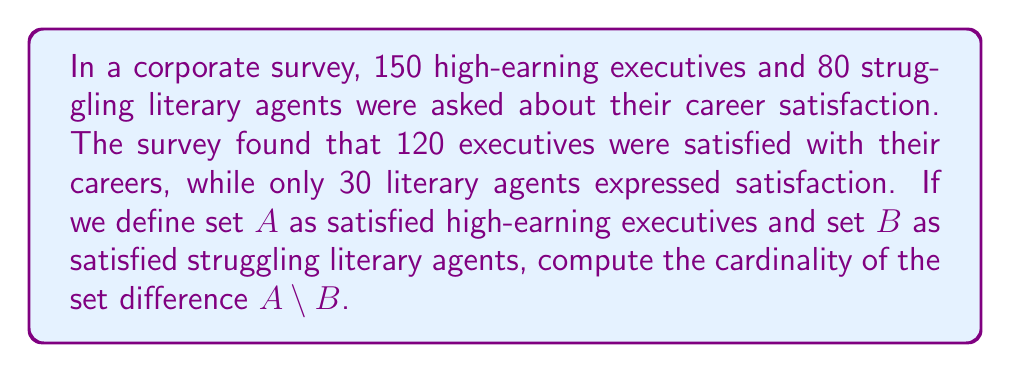Could you help me with this problem? To solve this problem, we need to follow these steps:

1) First, let's define our sets:
   A = {satisfied high-earning executives}
   B = {satisfied struggling literary agents}

2) We're given the following information:
   - Total number of high-earning executives: 150
   - Total number of struggling literary agents: 80
   - Number of satisfied high-earning executives: 120
   - Number of satisfied struggling literary agents: 30

3) The set difference A \ B is defined as the elements that are in A but not in B.

4) In this case, all elements of A are automatically not in B, because A and B are disjoint sets (no one can be both a high-earning executive and a struggling literary agent simultaneously).

5) Therefore, the cardinality of A \ B is simply the cardinality of A:

   $$|A \setminus B| = |A| = 120$$

This result shows that there are 120 satisfied high-earning executives who are not satisfied struggling literary agents, which is exactly what we'd expect given the disjoint nature of these sets.
Answer: 120 